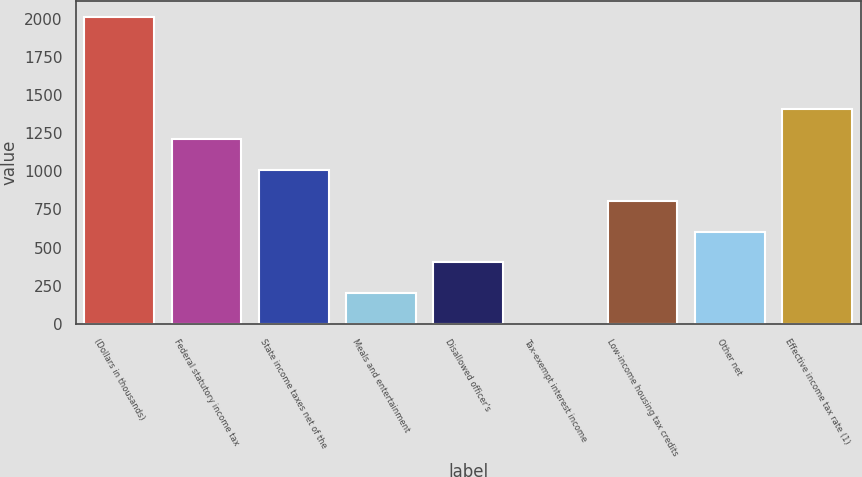<chart> <loc_0><loc_0><loc_500><loc_500><bar_chart><fcel>(Dollars in thousands)<fcel>Federal statutory income tax<fcel>State income taxes net of the<fcel>Meals and entertainment<fcel>Disallowed officer's<fcel>Tax-exempt interest income<fcel>Low-income housing tax credits<fcel>Other net<fcel>Effective income tax rate (1)<nl><fcel>2015<fcel>1209.08<fcel>1007.6<fcel>201.68<fcel>403.16<fcel>0.2<fcel>806.12<fcel>604.64<fcel>1410.56<nl></chart> 